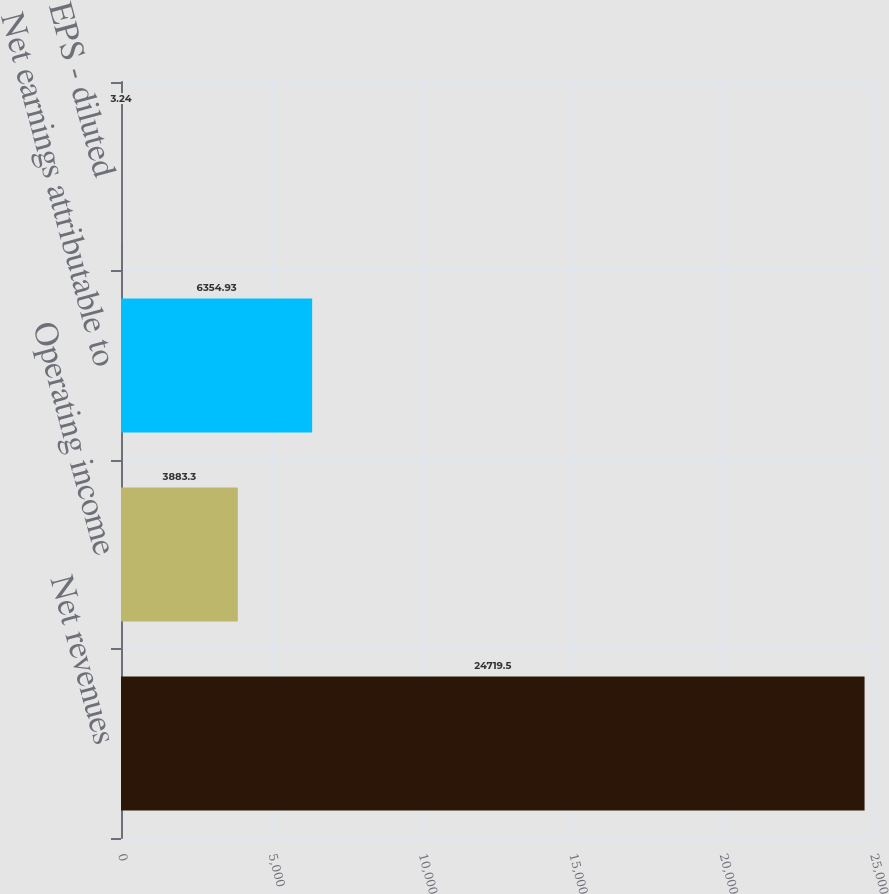Convert chart. <chart><loc_0><loc_0><loc_500><loc_500><bar_chart><fcel>Net revenues<fcel>Operating income<fcel>Net earnings attributable to<fcel>EPS - diluted<nl><fcel>24719.5<fcel>3883.3<fcel>6354.93<fcel>3.24<nl></chart> 